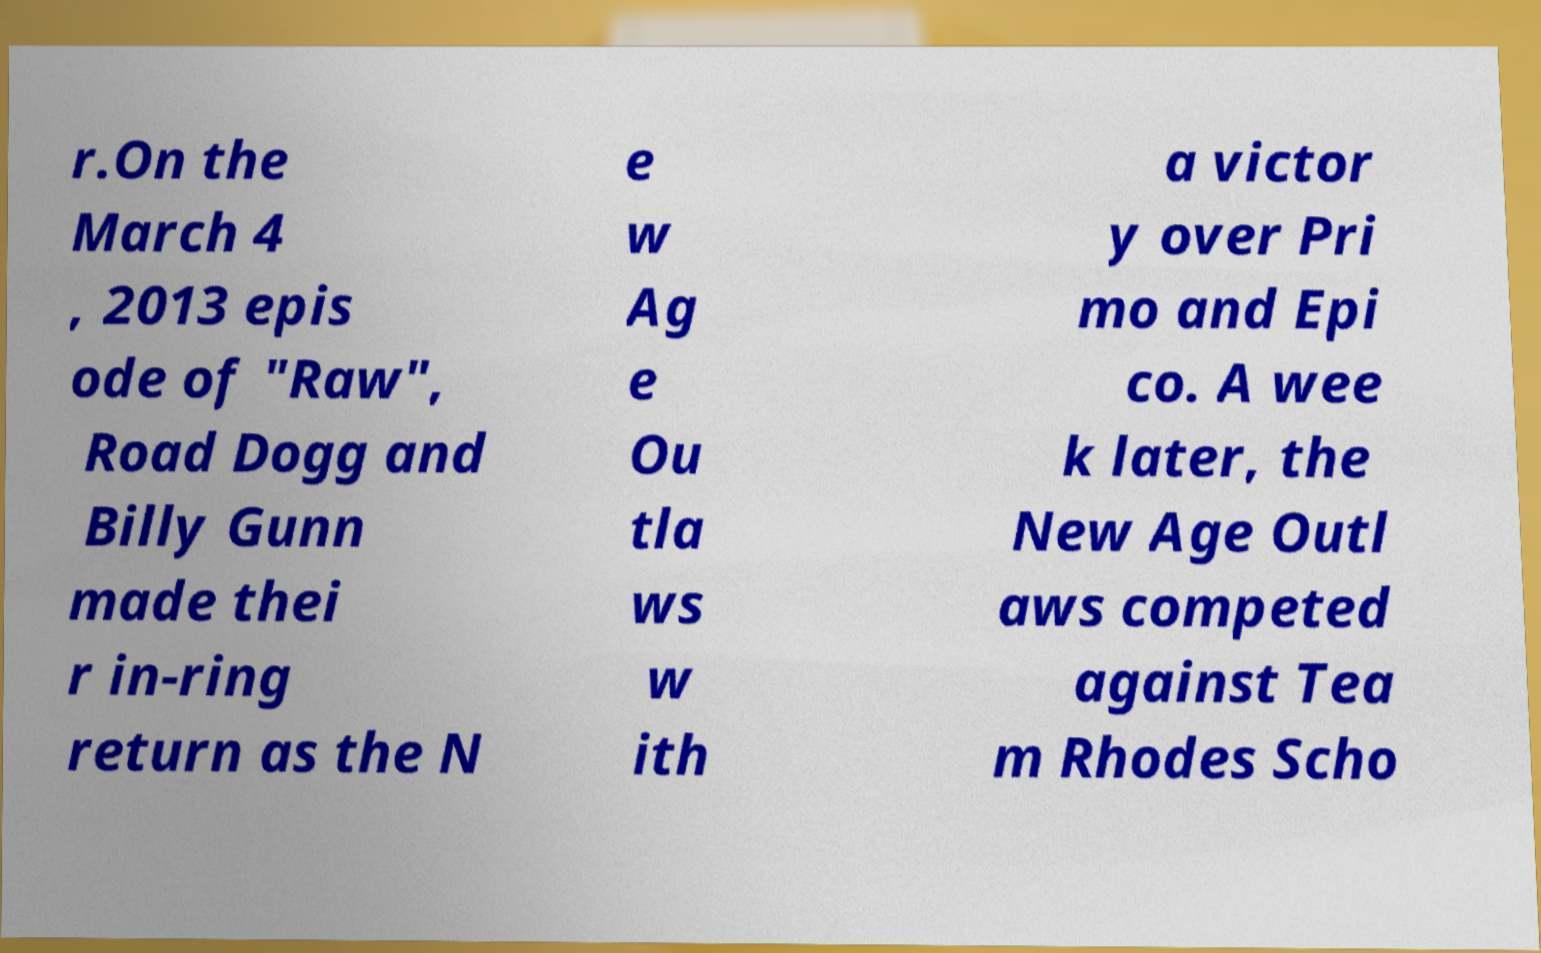Could you assist in decoding the text presented in this image and type it out clearly? r.On the March 4 , 2013 epis ode of "Raw", Road Dogg and Billy Gunn made thei r in-ring return as the N e w Ag e Ou tla ws w ith a victor y over Pri mo and Epi co. A wee k later, the New Age Outl aws competed against Tea m Rhodes Scho 